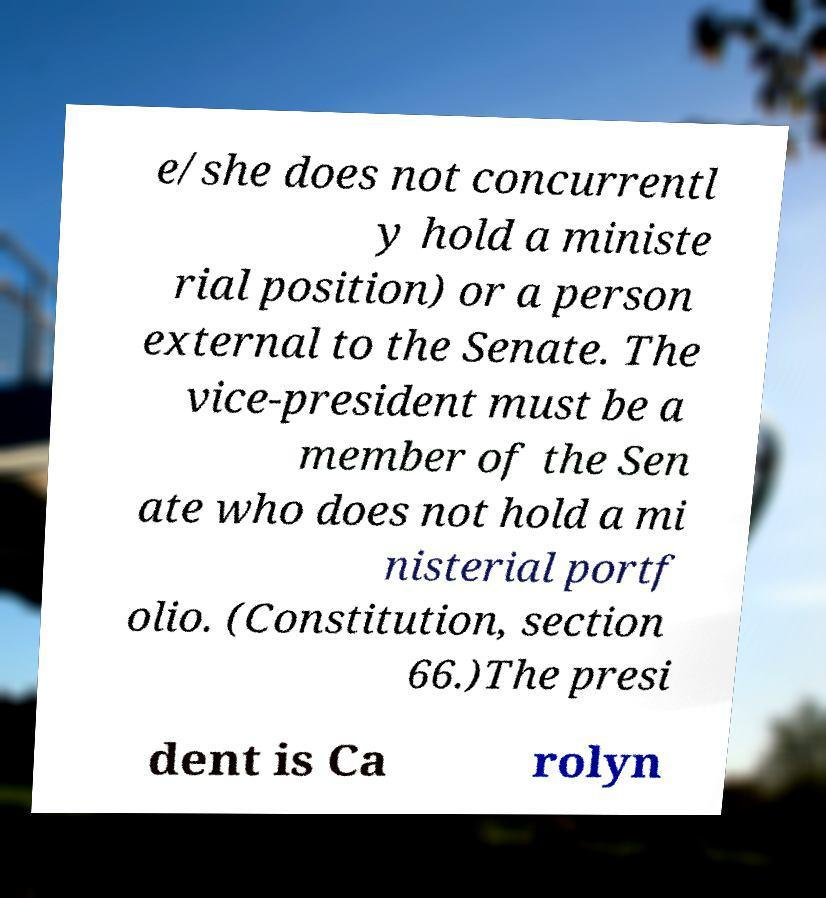For documentation purposes, I need the text within this image transcribed. Could you provide that? e/she does not concurrentl y hold a ministe rial position) or a person external to the Senate. The vice-president must be a member of the Sen ate who does not hold a mi nisterial portf olio. (Constitution, section 66.)The presi dent is Ca rolyn 